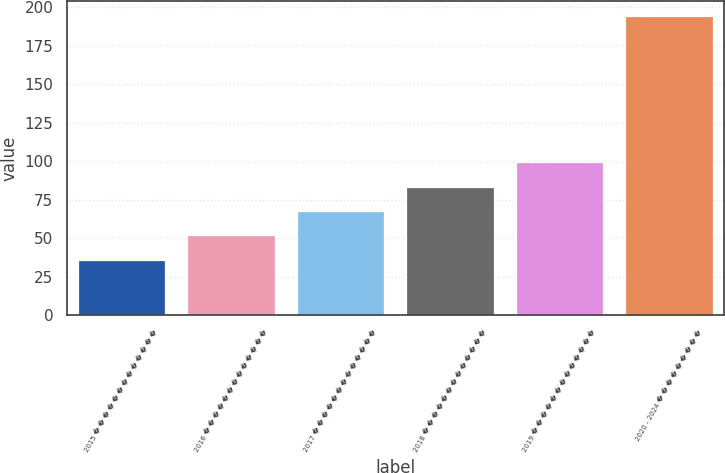Convert chart to OTSL. <chart><loc_0><loc_0><loc_500><loc_500><bar_chart><fcel>2015 � � � � � � � � � � � � �<fcel>2016 � � � � � � � � � � � � �<fcel>2017 � � � � � � � � � � � � �<fcel>2018 � � � � � � � � � � � � �<fcel>2019 � � � � � � � � � � � � �<fcel>2020 - 2024 � � � � � � � � �<nl><fcel>36<fcel>51.8<fcel>67.6<fcel>83.4<fcel>99.2<fcel>194<nl></chart> 